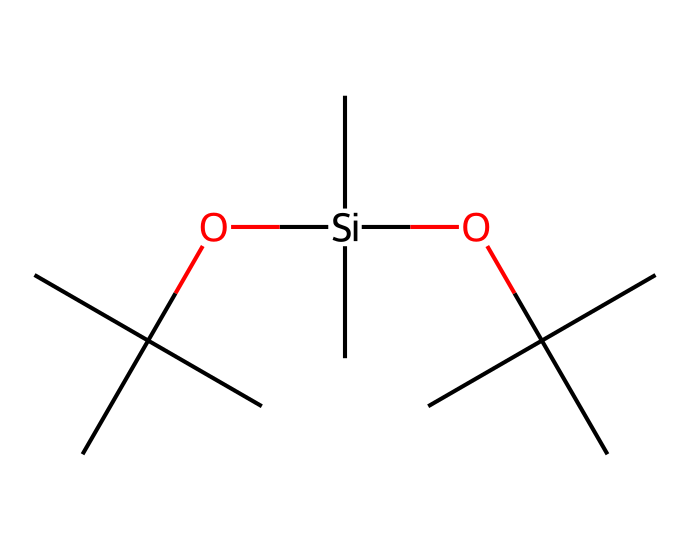What is the central element in this organosilicon compound? The chemical structure contains a silicon atom at the center, bonded to several carbon and oxygen atoms. Thus, silicon is the central element.
Answer: silicon How many carbon atoms are present in this compound? By analyzing the SMILES representation, there are a total of 9 carbon atoms represented, as counted directly from the structure.
Answer: 9 What functional group is present in this organosilicon compound? The presence of -O- indicates that there are ether functional groups within the structure, which specifically identifies it as an ether.
Answer: ether What is the degree of branching in this compound? The compound shows extensive branching due to multiple substituents attached to the silicon atom, especially tertiary butyl groups, indicating a high degree of branching.
Answer: high What type of bond connects silicon to oxygen in this compound? The bond formed between silicon and oxygen in this compound is a sigma bond, as is typical for connections with silicon, involving single covalent bonds.
Answer: sigma bond Why might this compound be used in noise-canceling headphones? The organosilicon structure likely provides elasticity and durability, important for ear cushions, enhancing comfort and noise isolation.
Answer: elasticity 